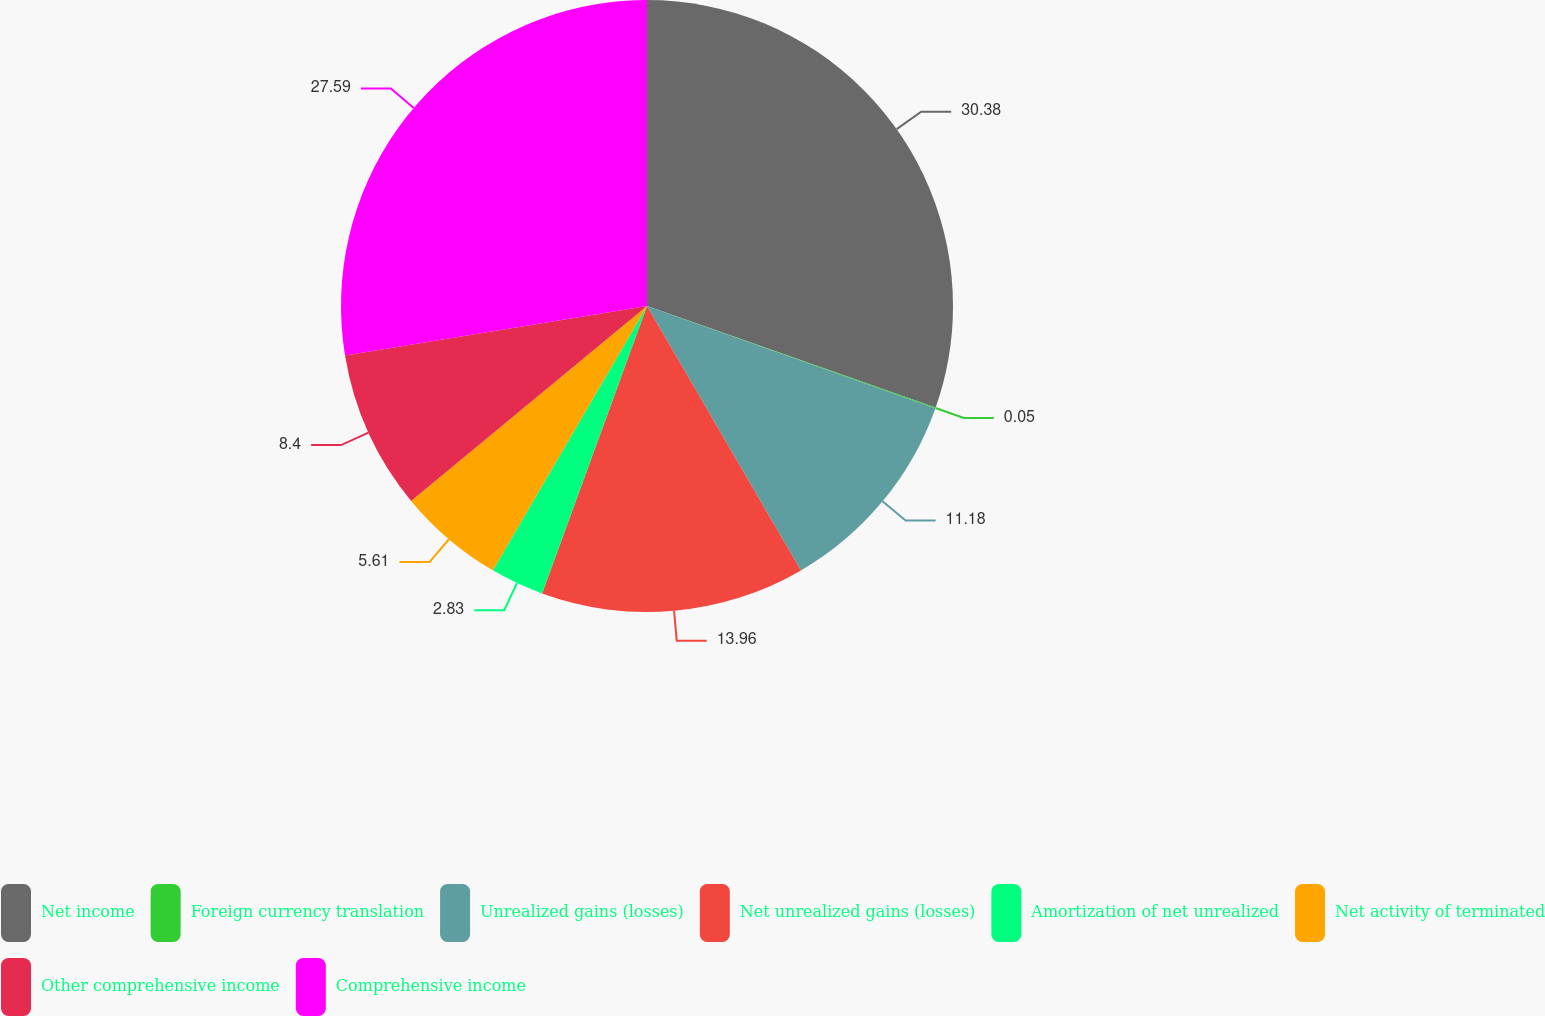Convert chart. <chart><loc_0><loc_0><loc_500><loc_500><pie_chart><fcel>Net income<fcel>Foreign currency translation<fcel>Unrealized gains (losses)<fcel>Net unrealized gains (losses)<fcel>Amortization of net unrealized<fcel>Net activity of terminated<fcel>Other comprehensive income<fcel>Comprehensive income<nl><fcel>30.38%<fcel>0.05%<fcel>11.18%<fcel>13.96%<fcel>2.83%<fcel>5.61%<fcel>8.4%<fcel>27.59%<nl></chart> 